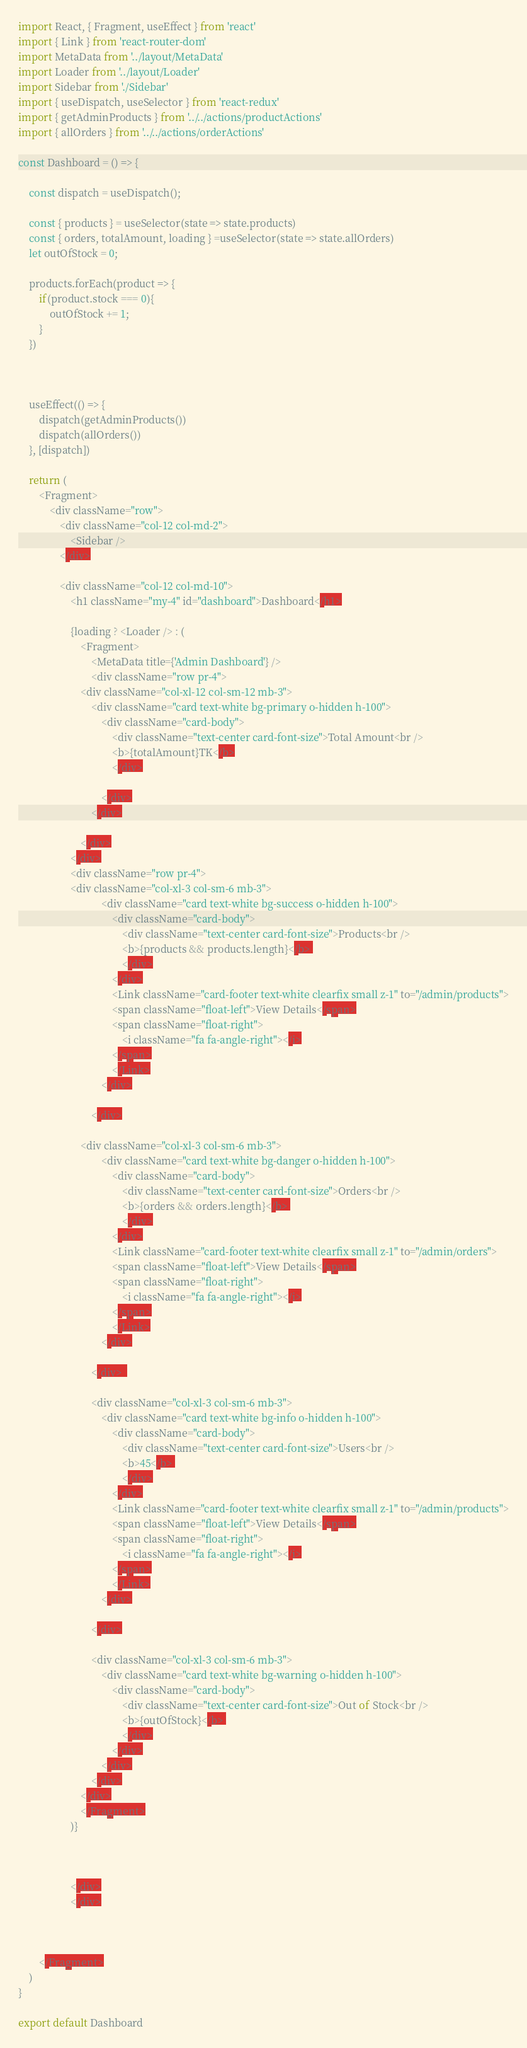Convert code to text. <code><loc_0><loc_0><loc_500><loc_500><_JavaScript_>import React, { Fragment, useEffect } from 'react'
import { Link } from 'react-router-dom'
import MetaData from '../layout/MetaData'
import Loader from '../layout/Loader'
import Sidebar from './Sidebar'
import { useDispatch, useSelector } from 'react-redux'
import { getAdminProducts } from '../../actions/productActions'
import { allOrders } from '../../actions/orderActions'

const Dashboard = () => {
    
    const dispatch = useDispatch();

    const { products } = useSelector(state => state.products)
    const { orders, totalAmount, loading } =useSelector(state => state.allOrders) 
    let outOfStock = 0;

    products.forEach(product => {
        if(product.stock === 0){
            outOfStock += 1;
        }
    })



    useEffect(() => {
        dispatch(getAdminProducts())
        dispatch(allOrders())
    }, [dispatch])

    return (
        <Fragment>
            <div className="row">
                <div className="col-12 col-md-2">
                    <Sidebar />
                </div>

                <div className="col-12 col-md-10">
                    <h1 className="my-4" id="dashboard">Dashboard</h1>

                    {loading ? <Loader /> : (
                        <Fragment>
                            <MetaData title={'Admin Dashboard'} />
                            <div className="row pr-4">
                        <div className="col-xl-12 col-sm-12 mb-3">
                            <div className="card text-white bg-primary o-hidden h-100">
                                <div className="card-body">
                                    <div className="text-center card-font-size">Total Amount<br />
                                    <b>{totalAmount}TK</b>
                                    </div>

                                </div>
                            </div>

                        </div>
                    </div>
                    <div className="row pr-4">
                    <div className="col-xl-3 col-sm-6 mb-3">
                                <div className="card text-white bg-success o-hidden h-100">
                                    <div className="card-body">
                                        <div className="text-center card-font-size">Products<br />
                                        <b>{products && products.length}</b> 
                                        </div>
                                    </div>
                                    <Link className="card-footer text-white clearfix small z-1" to="/admin/products">
                                    <span className="float-left">View Details</span>
                                    <span className="float-right">
                                        <i className="fa fa-angle-right"></i>
                                    </span>
                                    </Link>
                                </div>

                            </div>
                        
                        <div className="col-xl-3 col-sm-6 mb-3">
                                <div className="card text-white bg-danger o-hidden h-100">
                                    <div className="card-body">
                                        <div className="text-center card-font-size">Orders<br />
                                        <b>{orders && orders.length}</b> 
                                        </div>
                                    </div>
                                    <Link className="card-footer text-white clearfix small z-1" to="/admin/orders">
                                    <span className="float-left">View Details</span>
                                    <span className="float-right">
                                        <i className="fa fa-angle-right"></i>
                                    </span>
                                    </Link>
                                </div>

                            </div>  

                            <div className="col-xl-3 col-sm-6 mb-3">
                                <div className="card text-white bg-info o-hidden h-100">
                                    <div className="card-body">
                                        <div className="text-center card-font-size">Users<br />
                                        <b>45</b> 
                                        </div>
                                    </div>
                                    <Link className="card-footer text-white clearfix small z-1" to="/admin/products">
                                    <span className="float-left">View Details</span>
                                    <span className="float-right">
                                        <i className="fa fa-angle-right"></i>
                                    </span>
                                    </Link>
                                </div>

                            </div>
                       
                            <div className="col-xl-3 col-sm-6 mb-3">
                                <div className="card text-white bg-warning o-hidden h-100">
                                    <div className="card-body">
                                        <div className="text-center card-font-size">Out of Stock<br />
                                        <b>{outOfStock}</b> 
                                        </div>
                                    </div>
                                </div>
                            </div>
                        </div>
                        </Fragment>
                    )}

                   

                    </div>
                    </div>
                
            
            
        </Fragment>
    )
}

export default Dashboard
</code> 